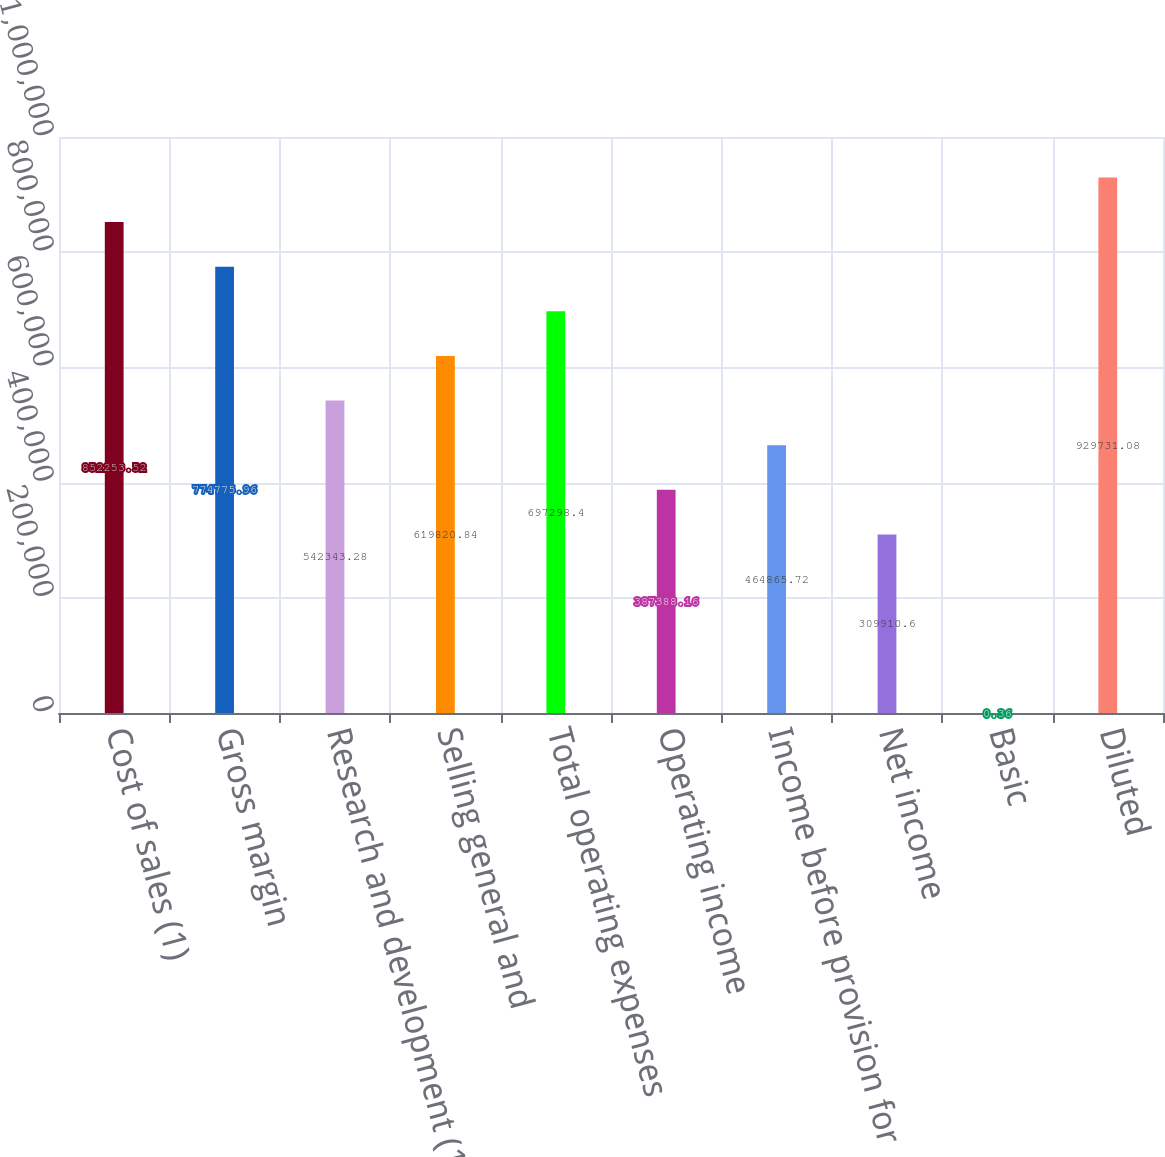<chart> <loc_0><loc_0><loc_500><loc_500><bar_chart><fcel>Cost of sales (1)<fcel>Gross margin<fcel>Research and development (1)<fcel>Selling general and<fcel>Total operating expenses<fcel>Operating income<fcel>Income before provision for<fcel>Net income<fcel>Basic<fcel>Diluted<nl><fcel>852254<fcel>774776<fcel>542343<fcel>619821<fcel>697298<fcel>387388<fcel>464866<fcel>309911<fcel>0.36<fcel>929731<nl></chart> 